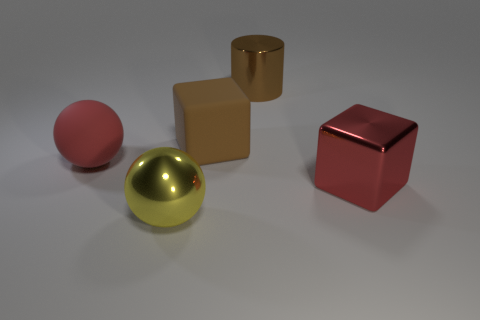Subtract all blue cylinders. Subtract all purple spheres. How many cylinders are left? 1 Add 4 big brown cubes. How many objects exist? 9 Subtract all blocks. How many objects are left? 3 Add 5 red metal things. How many red metal things are left? 6 Add 1 big green shiny cubes. How many big green shiny cubes exist? 1 Subtract 0 cyan cubes. How many objects are left? 5 Subtract all large blocks. Subtract all yellow objects. How many objects are left? 2 